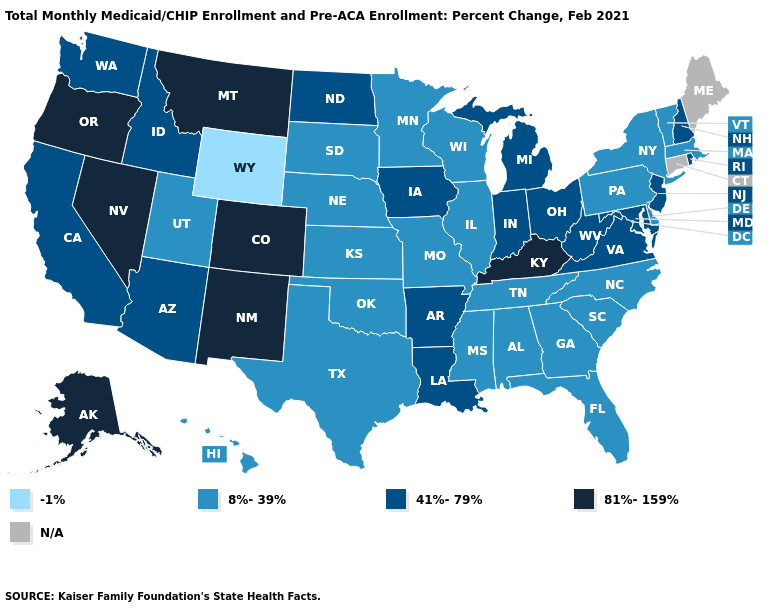Name the states that have a value in the range -1%?
Concise answer only. Wyoming. Does the first symbol in the legend represent the smallest category?
Write a very short answer. Yes. Does the map have missing data?
Write a very short answer. Yes. Among the states that border New Mexico , which have the highest value?
Concise answer only. Colorado. What is the value of Montana?
Quick response, please. 81%-159%. What is the value of Colorado?
Concise answer only. 81%-159%. What is the value of Massachusetts?
Answer briefly. 8%-39%. What is the highest value in the West ?
Concise answer only. 81%-159%. What is the highest value in the South ?
Be succinct. 81%-159%. What is the highest value in states that border Pennsylvania?
Concise answer only. 41%-79%. Which states have the lowest value in the South?
Quick response, please. Alabama, Delaware, Florida, Georgia, Mississippi, North Carolina, Oklahoma, South Carolina, Tennessee, Texas. Does Florida have the lowest value in the USA?
Be succinct. No. 